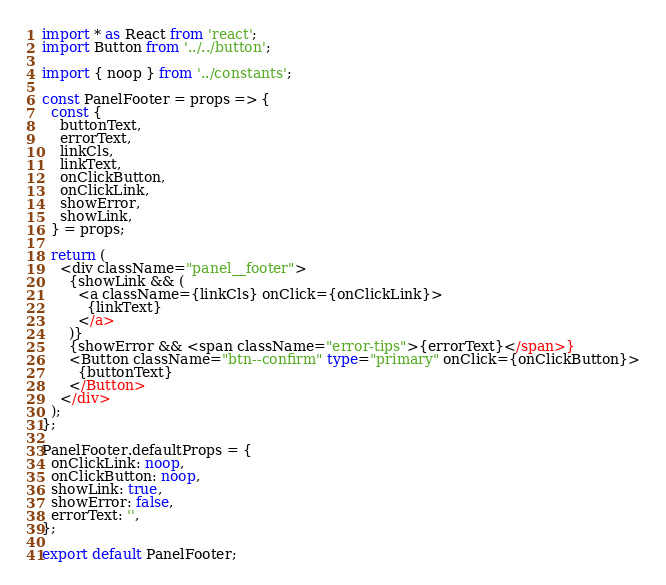<code> <loc_0><loc_0><loc_500><loc_500><_TypeScript_>import * as React from 'react';
import Button from '../../button';

import { noop } from '../constants';

const PanelFooter = props => {
  const {
    buttonText,
    errorText,
    linkCls,
    linkText,
    onClickButton,
    onClickLink,
    showError,
    showLink,
  } = props;

  return (
    <div className="panel__footer">
      {showLink && (
        <a className={linkCls} onClick={onClickLink}>
          {linkText}
        </a>
      )}
      {showError && <span className="error-tips">{errorText}</span>}
      <Button className="btn--confirm" type="primary" onClick={onClickButton}>
        {buttonText}
      </Button>
    </div>
  );
};

PanelFooter.defaultProps = {
  onClickLink: noop,
  onClickButton: noop,
  showLink: true,
  showError: false,
  errorText: '',
};

export default PanelFooter;
</code> 